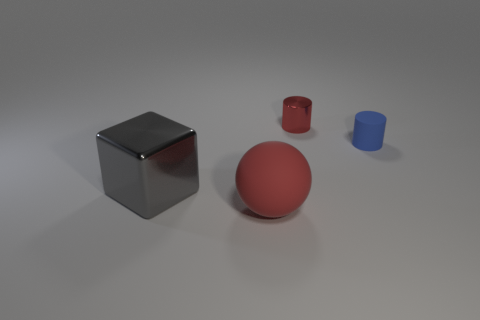Add 2 red matte objects. How many objects exist? 6 Subtract all cubes. How many objects are left? 3 Subtract all brown cubes. Subtract all blue balls. How many cubes are left? 1 Subtract all tiny blue matte things. Subtract all rubber spheres. How many objects are left? 2 Add 3 small rubber objects. How many small rubber objects are left? 4 Add 3 small purple shiny blocks. How many small purple shiny blocks exist? 3 Subtract 0 gray balls. How many objects are left? 4 Subtract 1 blocks. How many blocks are left? 0 